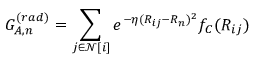<formula> <loc_0><loc_0><loc_500><loc_500>G _ { A , n } ^ { ( r a d ) } = \sum _ { j \in \mathcal { N } [ i ] } e ^ { - \eta ( R _ { i j } - R _ { n } ) ^ { 2 } } f _ { C } ( R _ { i j } )</formula> 